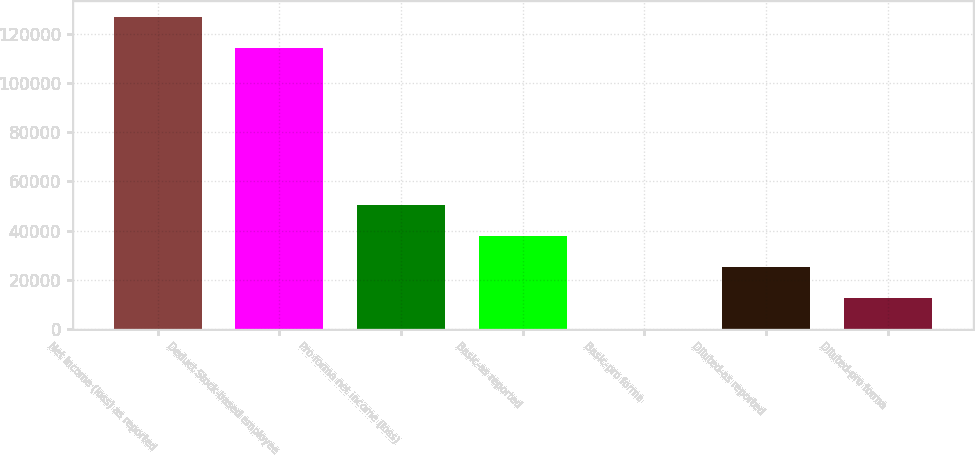Convert chart to OTSL. <chart><loc_0><loc_0><loc_500><loc_500><bar_chart><fcel>Net income (loss) as reported<fcel>Deduct Stock-based employee<fcel>Pro forma net income (loss)<fcel>Basic-as reported<fcel>Basic-pro forma<fcel>Diluted-as reported<fcel>Diluted-pro forma<nl><fcel>126904<fcel>114334<fcel>50282<fcel>37711.5<fcel>0.03<fcel>25141<fcel>12570.5<nl></chart> 